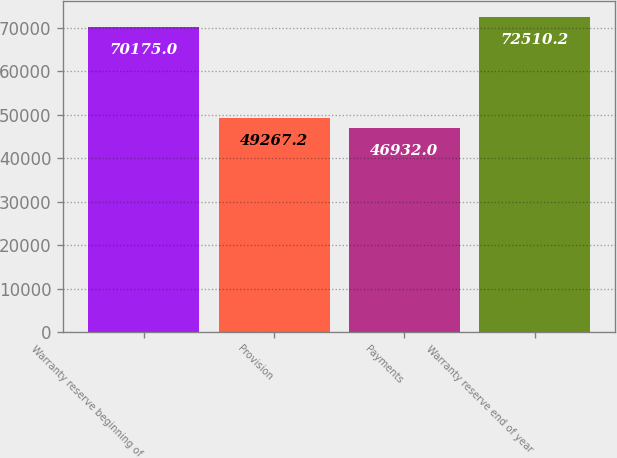Convert chart to OTSL. <chart><loc_0><loc_0><loc_500><loc_500><bar_chart><fcel>Warranty reserve beginning of<fcel>Provision<fcel>Payments<fcel>Warranty reserve end of year<nl><fcel>70175<fcel>49267.2<fcel>46932<fcel>72510.2<nl></chart> 